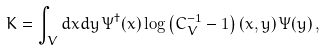<formula> <loc_0><loc_0><loc_500><loc_500>K = \int _ { V } d x d y \, \Psi ^ { \dagger } ( x ) \log \left ( C _ { V } ^ { - 1 } - 1 \right ) ( x , y ) \, \Psi ( y ) \, ,</formula> 